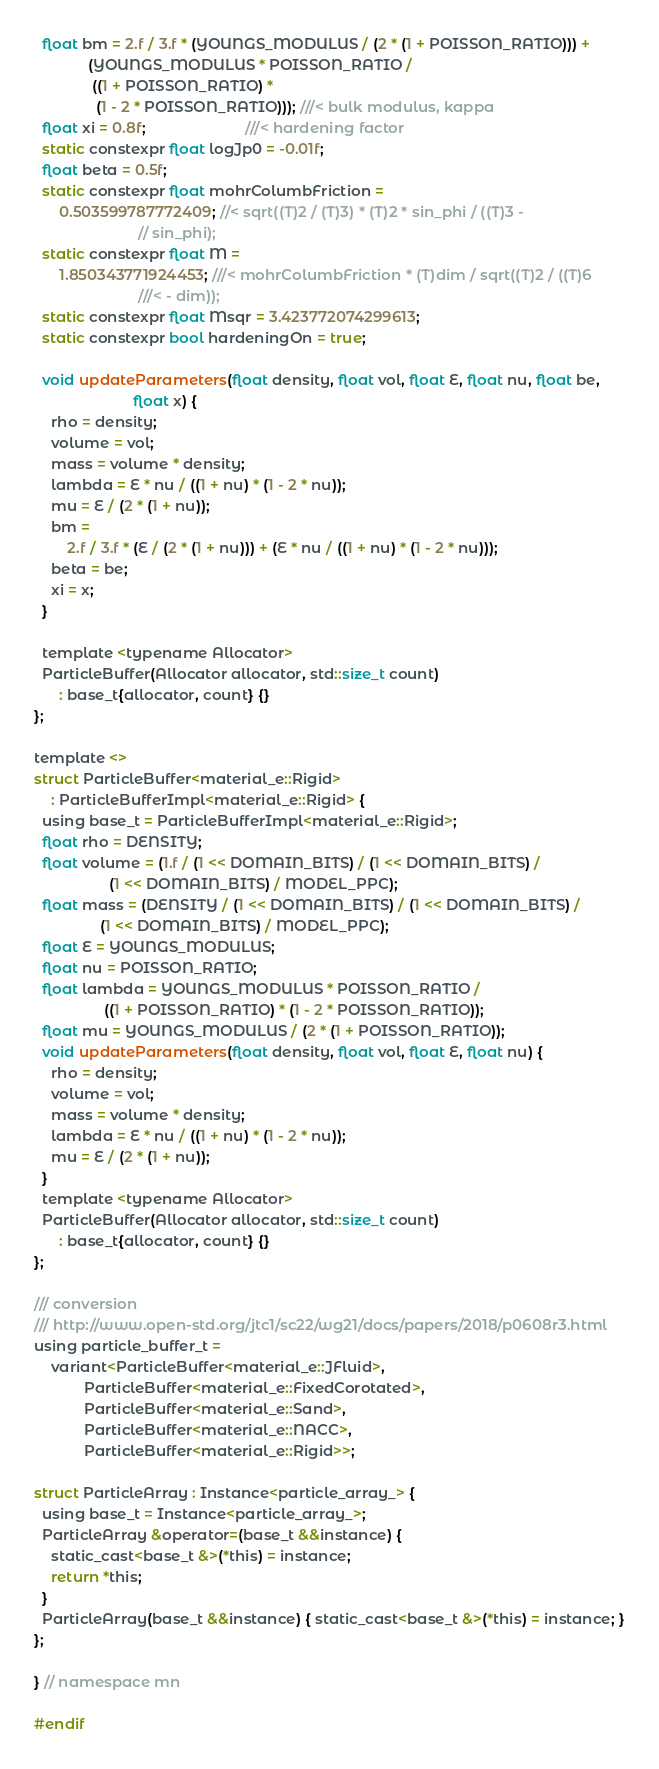<code> <loc_0><loc_0><loc_500><loc_500><_Cuda_>  float bm = 2.f / 3.f * (YOUNGS_MODULUS / (2 * (1 + POISSON_RATIO))) +
             (YOUNGS_MODULUS * POISSON_RATIO /
              ((1 + POISSON_RATIO) *
               (1 - 2 * POISSON_RATIO))); ///< bulk modulus, kappa
  float xi = 0.8f;                        ///< hardening factor
  static constexpr float logJp0 = -0.01f;
  float beta = 0.5f;
  static constexpr float mohrColumbFriction =
      0.503599787772409; //< sqrt((T)2 / (T)3) * (T)2 * sin_phi / ((T)3 -
                         // sin_phi);
  static constexpr float M =
      1.850343771924453; ///< mohrColumbFriction * (T)dim / sqrt((T)2 / ((T)6
                         ///< - dim));
  static constexpr float Msqr = 3.423772074299613;
  static constexpr bool hardeningOn = true;

  void updateParameters(float density, float vol, float E, float nu, float be,
                        float x) {
    rho = density;
    volume = vol;
    mass = volume * density;
    lambda = E * nu / ((1 + nu) * (1 - 2 * nu));
    mu = E / (2 * (1 + nu));
    bm =
        2.f / 3.f * (E / (2 * (1 + nu))) + (E * nu / ((1 + nu) * (1 - 2 * nu)));
    beta = be;
    xi = x;
  }

  template <typename Allocator>
  ParticleBuffer(Allocator allocator, std::size_t count)
      : base_t{allocator, count} {}
};

template <>
struct ParticleBuffer<material_e::Rigid>
    : ParticleBufferImpl<material_e::Rigid> {
  using base_t = ParticleBufferImpl<material_e::Rigid>;
  float rho = DENSITY;
  float volume = (1.f / (1 << DOMAIN_BITS) / (1 << DOMAIN_BITS) /
                  (1 << DOMAIN_BITS) / MODEL_PPC);
  float mass = (DENSITY / (1 << DOMAIN_BITS) / (1 << DOMAIN_BITS) /
                (1 << DOMAIN_BITS) / MODEL_PPC);
  float E = YOUNGS_MODULUS;
  float nu = POISSON_RATIO;
  float lambda = YOUNGS_MODULUS * POISSON_RATIO /
                 ((1 + POISSON_RATIO) * (1 - 2 * POISSON_RATIO));
  float mu = YOUNGS_MODULUS / (2 * (1 + POISSON_RATIO));
  void updateParameters(float density, float vol, float E, float nu) {
    rho = density;
    volume = vol;
    mass = volume * density;
    lambda = E * nu / ((1 + nu) * (1 - 2 * nu));
    mu = E / (2 * (1 + nu));
  }
  template <typename Allocator>
  ParticleBuffer(Allocator allocator, std::size_t count)
      : base_t{allocator, count} {}
};

/// conversion
/// http://www.open-std.org/jtc1/sc22/wg21/docs/papers/2018/p0608r3.html
using particle_buffer_t =
    variant<ParticleBuffer<material_e::JFluid>,
            ParticleBuffer<material_e::FixedCorotated>,
            ParticleBuffer<material_e::Sand>, 
            ParticleBuffer<material_e::NACC>, 
            ParticleBuffer<material_e::Rigid>>;

struct ParticleArray : Instance<particle_array_> {
  using base_t = Instance<particle_array_>;
  ParticleArray &operator=(base_t &&instance) {
    static_cast<base_t &>(*this) = instance;
    return *this;
  }
  ParticleArray(base_t &&instance) { static_cast<base_t &>(*this) = instance; }
};

} // namespace mn

#endif</code> 